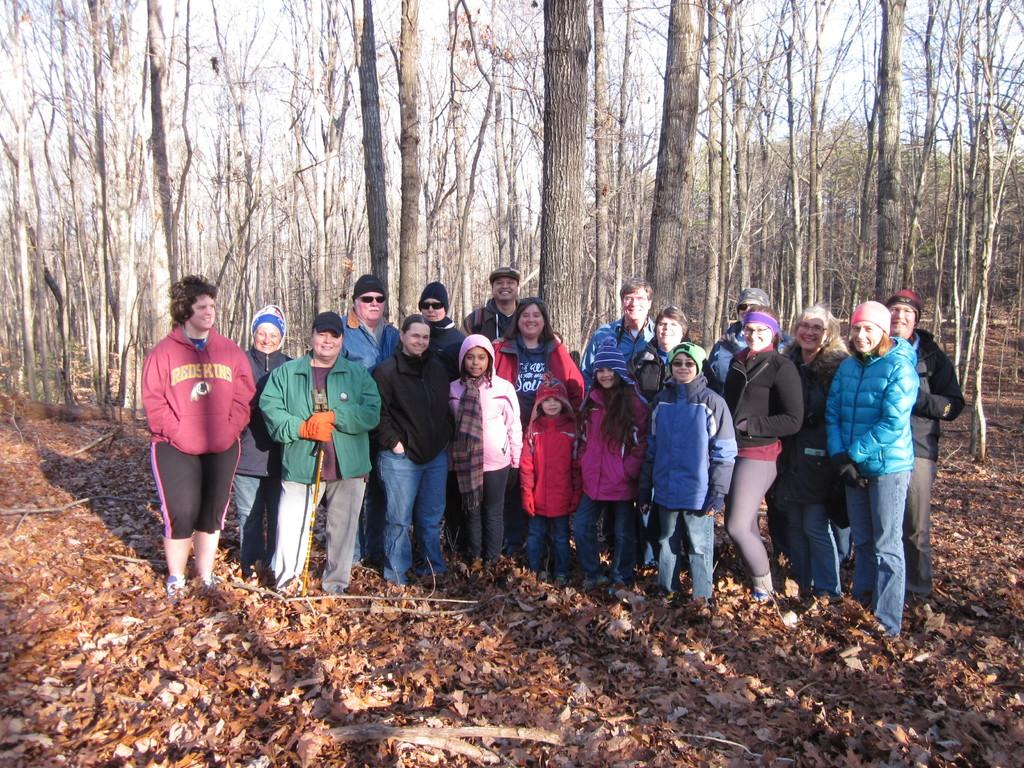Where was the image taken? The image was clicked outside. What can be seen in the middle of the image? There are trees and multiple persons in the middle of the image. What type of vegetation is visible at the bottom of the image? Leaves are visible at the bottom of the image. Who are the people in the image? There are men, women, and children present in the image. What type of punishment is being carried out in the image? There is no punishment being carried out in the image; it features trees and multiple persons. What is the oven used for in the image? There is no oven present in the image. 